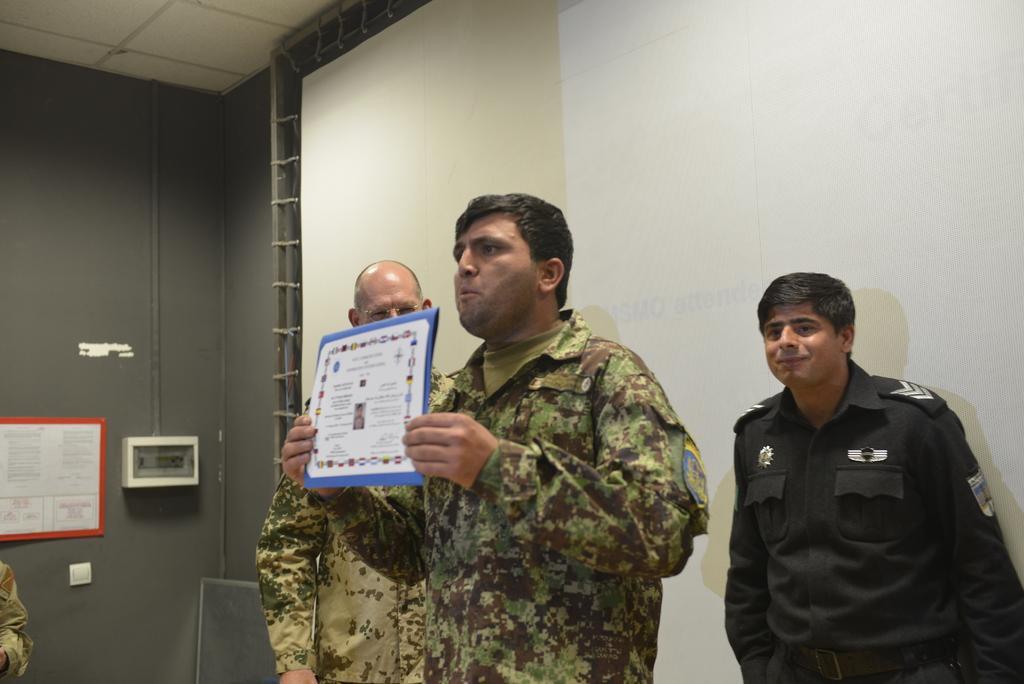Please provide a concise description of this image. In the middle of the image a person is standing and holding a paper. Behind him two persons are standing. Behind them there is wall, on the wall we can see a banner. In the top left corner of the image we can see ceiling. 